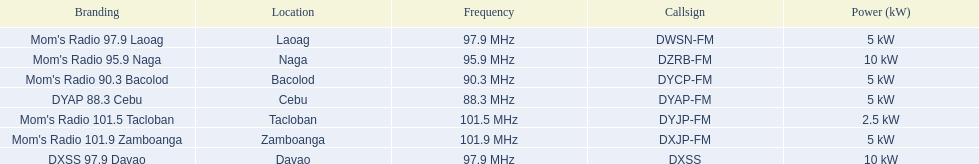What is the power capacity in kw for each team? 5 kW, 10 kW, 5 kW, 5 kW, 2.5 kW, 5 kW, 10 kW. Which is the lowest? 2.5 kW. What station has this amount of power? Mom's Radio 101.5 Tacloban. 